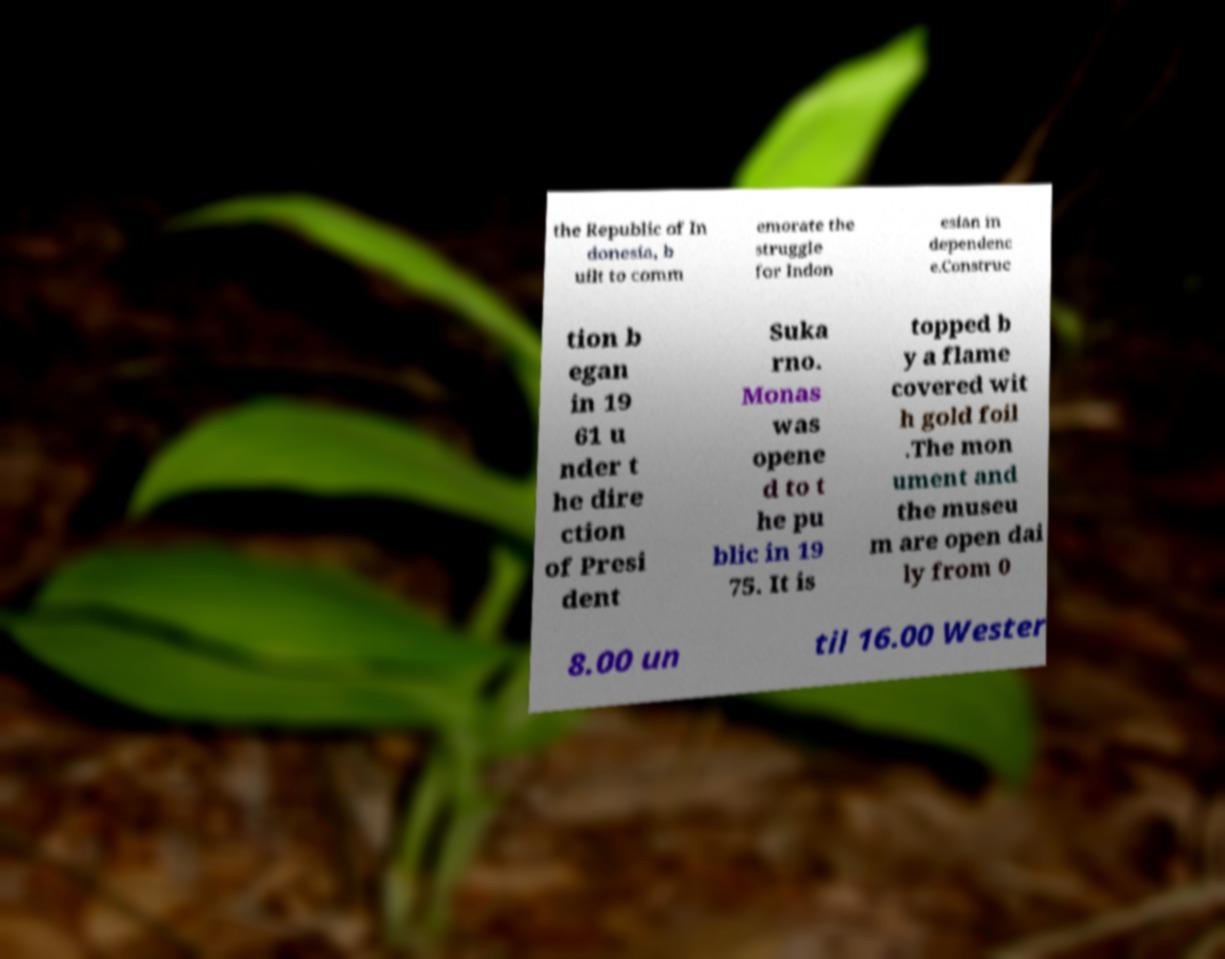There's text embedded in this image that I need extracted. Can you transcribe it verbatim? the Republic of In donesia, b uilt to comm emorate the struggle for Indon esian in dependenc e.Construc tion b egan in 19 61 u nder t he dire ction of Presi dent Suka rno. Monas was opene d to t he pu blic in 19 75. It is topped b y a flame covered wit h gold foil .The mon ument and the museu m are open dai ly from 0 8.00 un til 16.00 Wester 